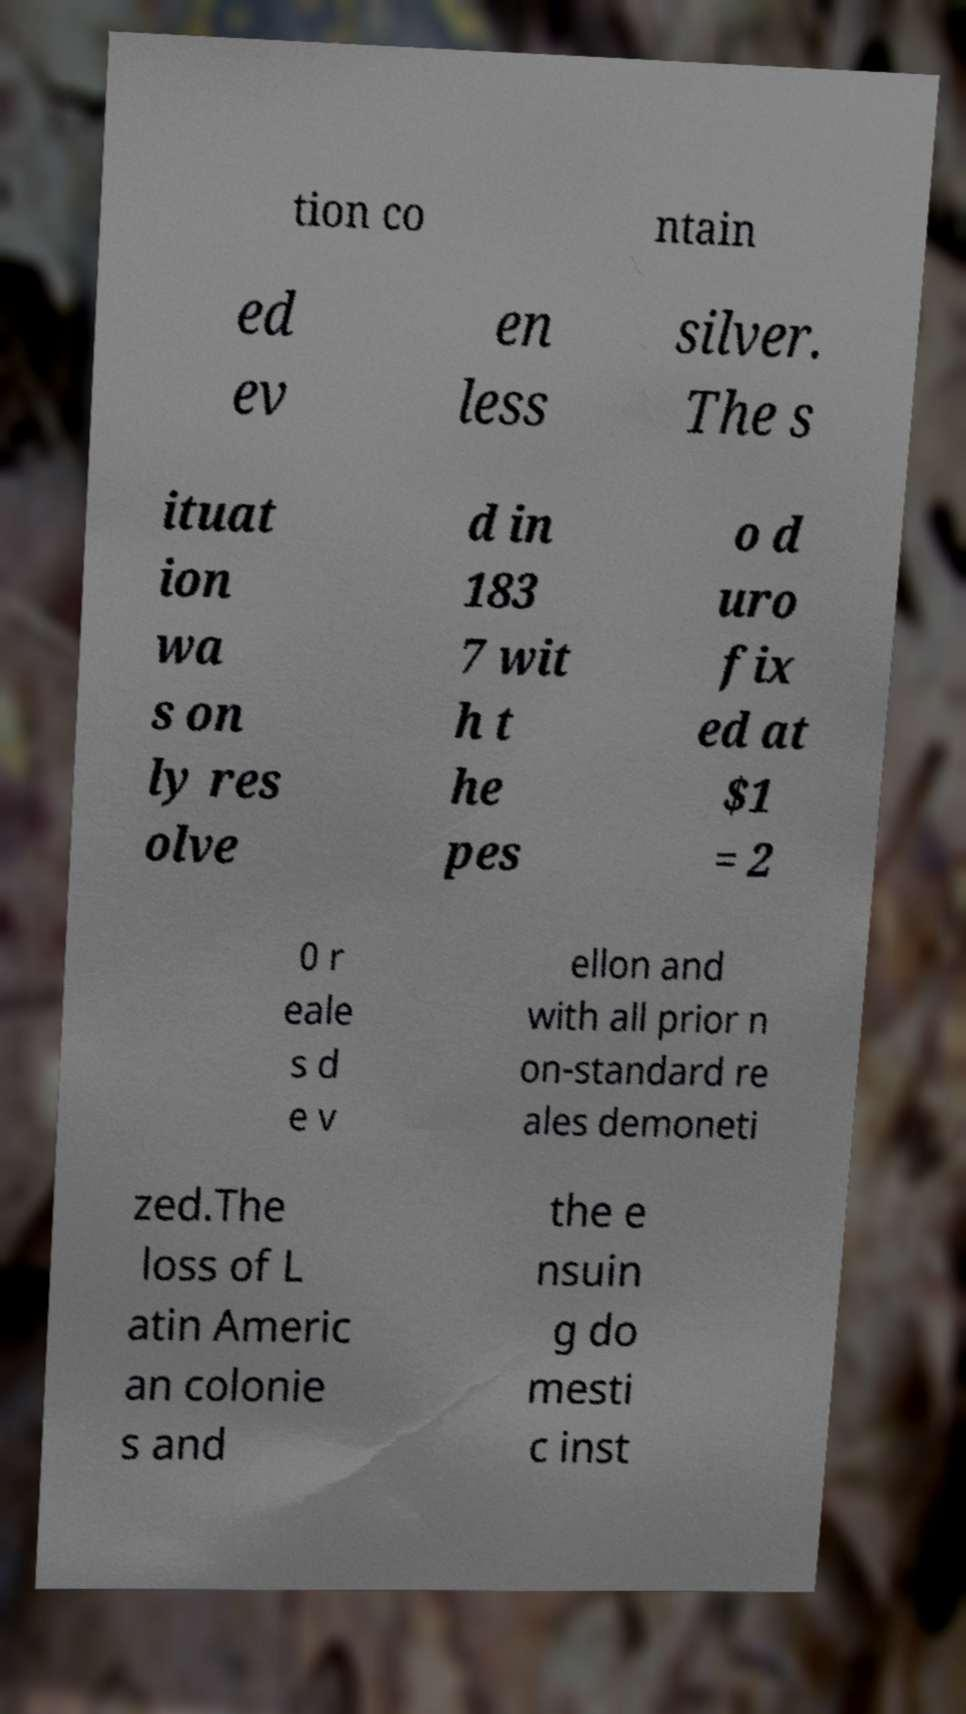For documentation purposes, I need the text within this image transcribed. Could you provide that? tion co ntain ed ev en less silver. The s ituat ion wa s on ly res olve d in 183 7 wit h t he pes o d uro fix ed at $1 = 2 0 r eale s d e v ellon and with all prior n on-standard re ales demoneti zed.The loss of L atin Americ an colonie s and the e nsuin g do mesti c inst 